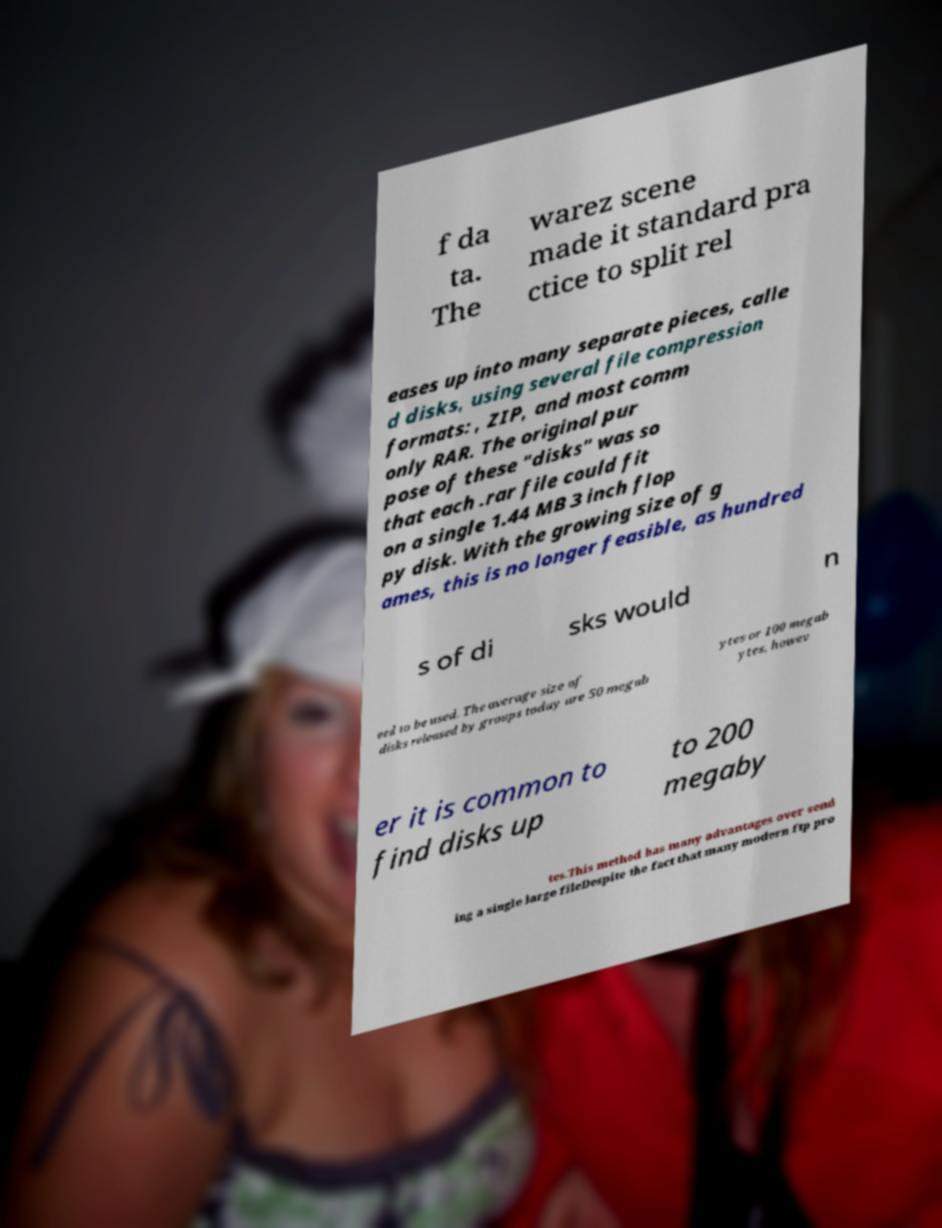There's text embedded in this image that I need extracted. Can you transcribe it verbatim? f da ta. The warez scene made it standard pra ctice to split rel eases up into many separate pieces, calle d disks, using several file compression formats: , ZIP, and most comm only RAR. The original pur pose of these "disks" was so that each .rar file could fit on a single 1.44 MB 3 inch flop py disk. With the growing size of g ames, this is no longer feasible, as hundred s of di sks would n eed to be used. The average size of disks released by groups today are 50 megab ytes or 100 megab ytes, howev er it is common to find disks up to 200 megaby tes.This method has many advantages over send ing a single large fileDespite the fact that many modern ftp pro 